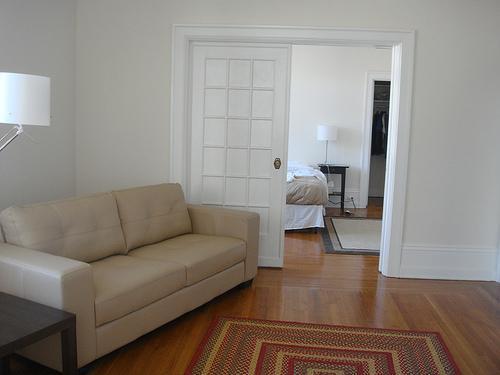How many couches are shown?
Give a very brief answer. 1. 